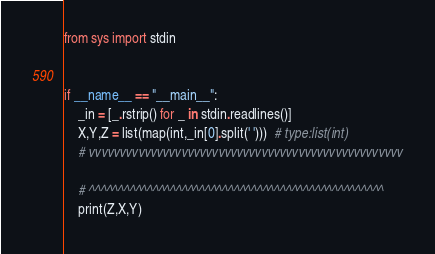<code> <loc_0><loc_0><loc_500><loc_500><_Python_>from sys import stdin


if __name__ == "__main__":
    _in = [_.rstrip() for _ in stdin.readlines()]
    X,Y,Z = list(map(int,_in[0].split(' ')))  # type:list(int)
    # vvvvvvvvvvvvvvvvvvvvvvvvvvvvvvvvvvvvvvvvvvvvvvvvvvv
    
    # ^^^^^^^^^^^^^^^^^^^^^^^^^^^^^^^^^^^^^^^^^^^^^^^^^^^
    print(Z,X,Y)</code> 